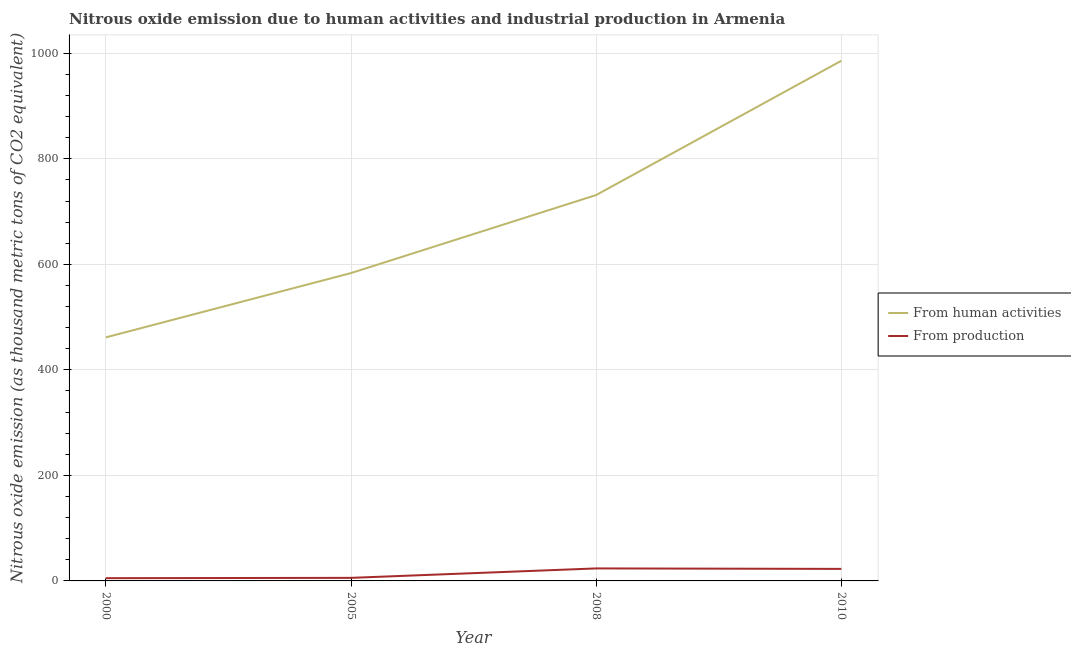Is the number of lines equal to the number of legend labels?
Offer a terse response. Yes. What is the amount of emissions from human activities in 2010?
Offer a terse response. 985.9. Across all years, what is the maximum amount of emissions generated from industries?
Your answer should be very brief. 23.7. Across all years, what is the minimum amount of emissions from human activities?
Your response must be concise. 461.6. In which year was the amount of emissions generated from industries maximum?
Offer a terse response. 2008. In which year was the amount of emissions from human activities minimum?
Ensure brevity in your answer.  2000. What is the total amount of emissions from human activities in the graph?
Give a very brief answer. 2762.4. What is the difference between the amount of emissions from human activities in 2010 and the amount of emissions generated from industries in 2000?
Provide a succinct answer. 980.7. What is the average amount of emissions generated from industries per year?
Offer a terse response. 14.38. In the year 2008, what is the difference between the amount of emissions generated from industries and amount of emissions from human activities?
Give a very brief answer. -707.7. What is the ratio of the amount of emissions from human activities in 2005 to that in 2008?
Give a very brief answer. 0.8. Is the amount of emissions from human activities in 2000 less than that in 2005?
Your answer should be very brief. Yes. Is the difference between the amount of emissions from human activities in 2005 and 2008 greater than the difference between the amount of emissions generated from industries in 2005 and 2008?
Your response must be concise. No. What is the difference between the highest and the second highest amount of emissions generated from industries?
Ensure brevity in your answer.  0.9. What is the difference between the highest and the lowest amount of emissions from human activities?
Keep it short and to the point. 524.3. In how many years, is the amount of emissions generated from industries greater than the average amount of emissions generated from industries taken over all years?
Provide a succinct answer. 2. Does the amount of emissions generated from industries monotonically increase over the years?
Provide a succinct answer. No. Is the amount of emissions from human activities strictly less than the amount of emissions generated from industries over the years?
Offer a terse response. No. How many lines are there?
Your response must be concise. 2. How many years are there in the graph?
Offer a very short reply. 4. How many legend labels are there?
Ensure brevity in your answer.  2. What is the title of the graph?
Offer a very short reply. Nitrous oxide emission due to human activities and industrial production in Armenia. What is the label or title of the X-axis?
Your response must be concise. Year. What is the label or title of the Y-axis?
Give a very brief answer. Nitrous oxide emission (as thousand metric tons of CO2 equivalent). What is the Nitrous oxide emission (as thousand metric tons of CO2 equivalent) in From human activities in 2000?
Provide a short and direct response. 461.6. What is the Nitrous oxide emission (as thousand metric tons of CO2 equivalent) of From production in 2000?
Your answer should be very brief. 5.2. What is the Nitrous oxide emission (as thousand metric tons of CO2 equivalent) of From human activities in 2005?
Provide a succinct answer. 583.5. What is the Nitrous oxide emission (as thousand metric tons of CO2 equivalent) in From human activities in 2008?
Give a very brief answer. 731.4. What is the Nitrous oxide emission (as thousand metric tons of CO2 equivalent) of From production in 2008?
Provide a succinct answer. 23.7. What is the Nitrous oxide emission (as thousand metric tons of CO2 equivalent) in From human activities in 2010?
Give a very brief answer. 985.9. What is the Nitrous oxide emission (as thousand metric tons of CO2 equivalent) in From production in 2010?
Provide a succinct answer. 22.8. Across all years, what is the maximum Nitrous oxide emission (as thousand metric tons of CO2 equivalent) of From human activities?
Your response must be concise. 985.9. Across all years, what is the maximum Nitrous oxide emission (as thousand metric tons of CO2 equivalent) of From production?
Your response must be concise. 23.7. Across all years, what is the minimum Nitrous oxide emission (as thousand metric tons of CO2 equivalent) of From human activities?
Provide a short and direct response. 461.6. Across all years, what is the minimum Nitrous oxide emission (as thousand metric tons of CO2 equivalent) in From production?
Offer a very short reply. 5.2. What is the total Nitrous oxide emission (as thousand metric tons of CO2 equivalent) in From human activities in the graph?
Your answer should be compact. 2762.4. What is the total Nitrous oxide emission (as thousand metric tons of CO2 equivalent) in From production in the graph?
Make the answer very short. 57.5. What is the difference between the Nitrous oxide emission (as thousand metric tons of CO2 equivalent) of From human activities in 2000 and that in 2005?
Provide a succinct answer. -121.9. What is the difference between the Nitrous oxide emission (as thousand metric tons of CO2 equivalent) of From human activities in 2000 and that in 2008?
Offer a very short reply. -269.8. What is the difference between the Nitrous oxide emission (as thousand metric tons of CO2 equivalent) in From production in 2000 and that in 2008?
Make the answer very short. -18.5. What is the difference between the Nitrous oxide emission (as thousand metric tons of CO2 equivalent) of From human activities in 2000 and that in 2010?
Your answer should be very brief. -524.3. What is the difference between the Nitrous oxide emission (as thousand metric tons of CO2 equivalent) in From production in 2000 and that in 2010?
Your answer should be very brief. -17.6. What is the difference between the Nitrous oxide emission (as thousand metric tons of CO2 equivalent) in From human activities in 2005 and that in 2008?
Keep it short and to the point. -147.9. What is the difference between the Nitrous oxide emission (as thousand metric tons of CO2 equivalent) of From production in 2005 and that in 2008?
Ensure brevity in your answer.  -17.9. What is the difference between the Nitrous oxide emission (as thousand metric tons of CO2 equivalent) of From human activities in 2005 and that in 2010?
Keep it short and to the point. -402.4. What is the difference between the Nitrous oxide emission (as thousand metric tons of CO2 equivalent) of From production in 2005 and that in 2010?
Your answer should be very brief. -17. What is the difference between the Nitrous oxide emission (as thousand metric tons of CO2 equivalent) in From human activities in 2008 and that in 2010?
Provide a succinct answer. -254.5. What is the difference between the Nitrous oxide emission (as thousand metric tons of CO2 equivalent) of From human activities in 2000 and the Nitrous oxide emission (as thousand metric tons of CO2 equivalent) of From production in 2005?
Your response must be concise. 455.8. What is the difference between the Nitrous oxide emission (as thousand metric tons of CO2 equivalent) in From human activities in 2000 and the Nitrous oxide emission (as thousand metric tons of CO2 equivalent) in From production in 2008?
Offer a terse response. 437.9. What is the difference between the Nitrous oxide emission (as thousand metric tons of CO2 equivalent) in From human activities in 2000 and the Nitrous oxide emission (as thousand metric tons of CO2 equivalent) in From production in 2010?
Offer a very short reply. 438.8. What is the difference between the Nitrous oxide emission (as thousand metric tons of CO2 equivalent) in From human activities in 2005 and the Nitrous oxide emission (as thousand metric tons of CO2 equivalent) in From production in 2008?
Keep it short and to the point. 559.8. What is the difference between the Nitrous oxide emission (as thousand metric tons of CO2 equivalent) in From human activities in 2005 and the Nitrous oxide emission (as thousand metric tons of CO2 equivalent) in From production in 2010?
Your answer should be compact. 560.7. What is the difference between the Nitrous oxide emission (as thousand metric tons of CO2 equivalent) of From human activities in 2008 and the Nitrous oxide emission (as thousand metric tons of CO2 equivalent) of From production in 2010?
Ensure brevity in your answer.  708.6. What is the average Nitrous oxide emission (as thousand metric tons of CO2 equivalent) in From human activities per year?
Provide a short and direct response. 690.6. What is the average Nitrous oxide emission (as thousand metric tons of CO2 equivalent) in From production per year?
Your answer should be compact. 14.38. In the year 2000, what is the difference between the Nitrous oxide emission (as thousand metric tons of CO2 equivalent) of From human activities and Nitrous oxide emission (as thousand metric tons of CO2 equivalent) of From production?
Offer a terse response. 456.4. In the year 2005, what is the difference between the Nitrous oxide emission (as thousand metric tons of CO2 equivalent) in From human activities and Nitrous oxide emission (as thousand metric tons of CO2 equivalent) in From production?
Keep it short and to the point. 577.7. In the year 2008, what is the difference between the Nitrous oxide emission (as thousand metric tons of CO2 equivalent) of From human activities and Nitrous oxide emission (as thousand metric tons of CO2 equivalent) of From production?
Make the answer very short. 707.7. In the year 2010, what is the difference between the Nitrous oxide emission (as thousand metric tons of CO2 equivalent) in From human activities and Nitrous oxide emission (as thousand metric tons of CO2 equivalent) in From production?
Give a very brief answer. 963.1. What is the ratio of the Nitrous oxide emission (as thousand metric tons of CO2 equivalent) of From human activities in 2000 to that in 2005?
Your response must be concise. 0.79. What is the ratio of the Nitrous oxide emission (as thousand metric tons of CO2 equivalent) in From production in 2000 to that in 2005?
Your answer should be very brief. 0.9. What is the ratio of the Nitrous oxide emission (as thousand metric tons of CO2 equivalent) of From human activities in 2000 to that in 2008?
Provide a succinct answer. 0.63. What is the ratio of the Nitrous oxide emission (as thousand metric tons of CO2 equivalent) of From production in 2000 to that in 2008?
Offer a very short reply. 0.22. What is the ratio of the Nitrous oxide emission (as thousand metric tons of CO2 equivalent) in From human activities in 2000 to that in 2010?
Keep it short and to the point. 0.47. What is the ratio of the Nitrous oxide emission (as thousand metric tons of CO2 equivalent) of From production in 2000 to that in 2010?
Give a very brief answer. 0.23. What is the ratio of the Nitrous oxide emission (as thousand metric tons of CO2 equivalent) in From human activities in 2005 to that in 2008?
Make the answer very short. 0.8. What is the ratio of the Nitrous oxide emission (as thousand metric tons of CO2 equivalent) of From production in 2005 to that in 2008?
Provide a short and direct response. 0.24. What is the ratio of the Nitrous oxide emission (as thousand metric tons of CO2 equivalent) in From human activities in 2005 to that in 2010?
Provide a short and direct response. 0.59. What is the ratio of the Nitrous oxide emission (as thousand metric tons of CO2 equivalent) of From production in 2005 to that in 2010?
Provide a succinct answer. 0.25. What is the ratio of the Nitrous oxide emission (as thousand metric tons of CO2 equivalent) of From human activities in 2008 to that in 2010?
Your answer should be compact. 0.74. What is the ratio of the Nitrous oxide emission (as thousand metric tons of CO2 equivalent) of From production in 2008 to that in 2010?
Ensure brevity in your answer.  1.04. What is the difference between the highest and the second highest Nitrous oxide emission (as thousand metric tons of CO2 equivalent) in From human activities?
Your answer should be very brief. 254.5. What is the difference between the highest and the second highest Nitrous oxide emission (as thousand metric tons of CO2 equivalent) in From production?
Your answer should be very brief. 0.9. What is the difference between the highest and the lowest Nitrous oxide emission (as thousand metric tons of CO2 equivalent) of From human activities?
Your answer should be compact. 524.3. What is the difference between the highest and the lowest Nitrous oxide emission (as thousand metric tons of CO2 equivalent) in From production?
Offer a very short reply. 18.5. 